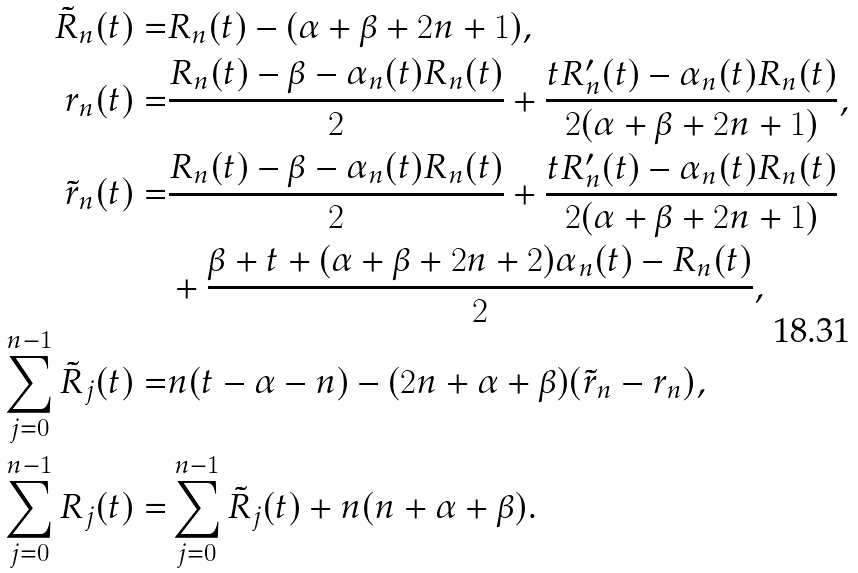Convert formula to latex. <formula><loc_0><loc_0><loc_500><loc_500>\tilde { R } _ { n } ( t ) = & R _ { n } ( t ) - ( \alpha + \beta + 2 n + 1 ) , \\ r _ { n } ( t ) = & \frac { R _ { n } ( t ) - \beta - \alpha _ { n } ( t ) R _ { n } ( t ) } { 2 } + \frac { t R ^ { \prime } _ { n } ( t ) - \alpha _ { n } ( t ) R _ { n } ( t ) } { 2 ( \alpha + \beta + 2 n + 1 ) } , \\ \tilde { r } _ { n } ( t ) = & \frac { R _ { n } ( t ) - \beta - \alpha _ { n } ( t ) R _ { n } ( t ) } { 2 } + \frac { t R ^ { \prime } _ { n } ( t ) - \alpha _ { n } ( t ) R _ { n } ( t ) } { 2 ( \alpha + \beta + 2 n + 1 ) } \\ & + \frac { \beta + t + ( \alpha + \beta + 2 n + 2 ) \alpha _ { n } ( t ) - R _ { n } ( t ) } { 2 } , \\ \sum _ { j = 0 } ^ { n - 1 } \tilde { R } _ { j } ( t ) = & n ( t - \alpha - n ) - ( 2 n + \alpha + \beta ) ( \tilde { r } _ { n } - r _ { n } ) , \\ \sum _ { j = 0 } ^ { n - 1 } R _ { j } ( t ) = & \sum _ { j = 0 } ^ { n - 1 } \tilde { R } _ { j } ( t ) + n ( n + \alpha + \beta ) .</formula> 